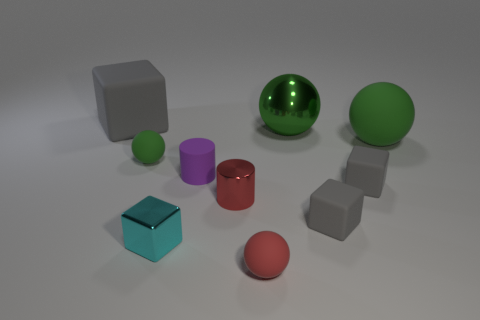Subtract all big green shiny spheres. How many spheres are left? 3 Subtract all red balls. How many balls are left? 3 Subtract 0 gray balls. How many objects are left? 10 Subtract all balls. How many objects are left? 6 Subtract 1 blocks. How many blocks are left? 3 Subtract all gray spheres. Subtract all red cubes. How many spheres are left? 4 Subtract all red cylinders. How many purple spheres are left? 0 Subtract all big brown blocks. Subtract all tiny spheres. How many objects are left? 8 Add 6 tiny green spheres. How many tiny green spheres are left? 7 Add 2 large green matte things. How many large green matte things exist? 3 